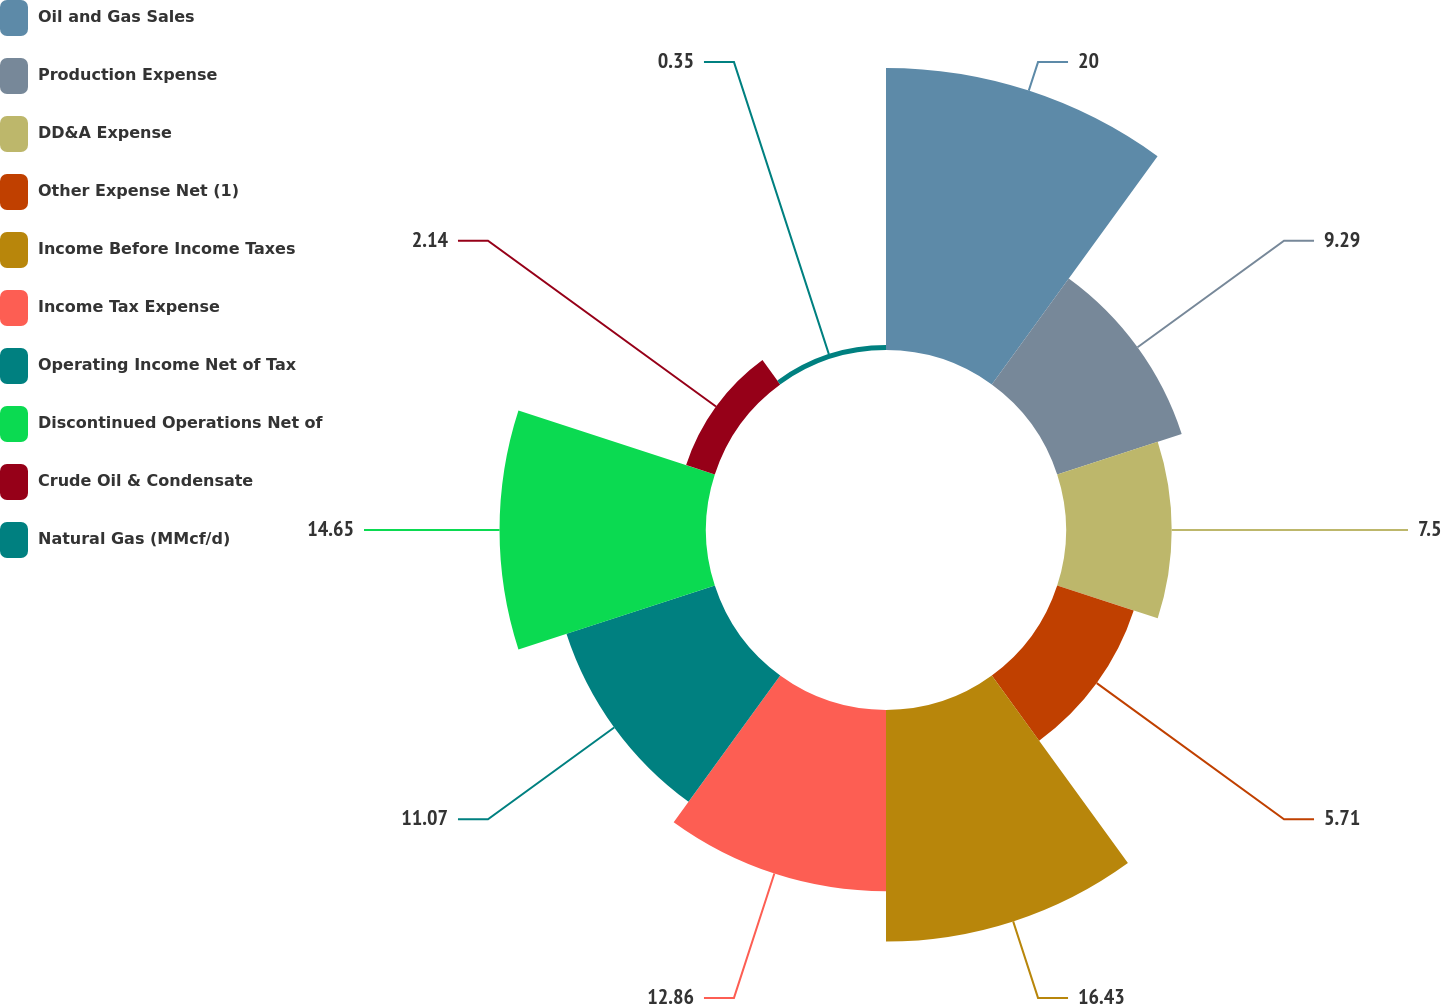Convert chart to OTSL. <chart><loc_0><loc_0><loc_500><loc_500><pie_chart><fcel>Oil and Gas Sales<fcel>Production Expense<fcel>DD&A Expense<fcel>Other Expense Net (1)<fcel>Income Before Income Taxes<fcel>Income Tax Expense<fcel>Operating Income Net of Tax<fcel>Discontinued Operations Net of<fcel>Crude Oil & Condensate<fcel>Natural Gas (MMcf/d)<nl><fcel>20.01%<fcel>9.29%<fcel>7.5%<fcel>5.71%<fcel>16.43%<fcel>12.86%<fcel>11.07%<fcel>14.65%<fcel>2.14%<fcel>0.35%<nl></chart> 